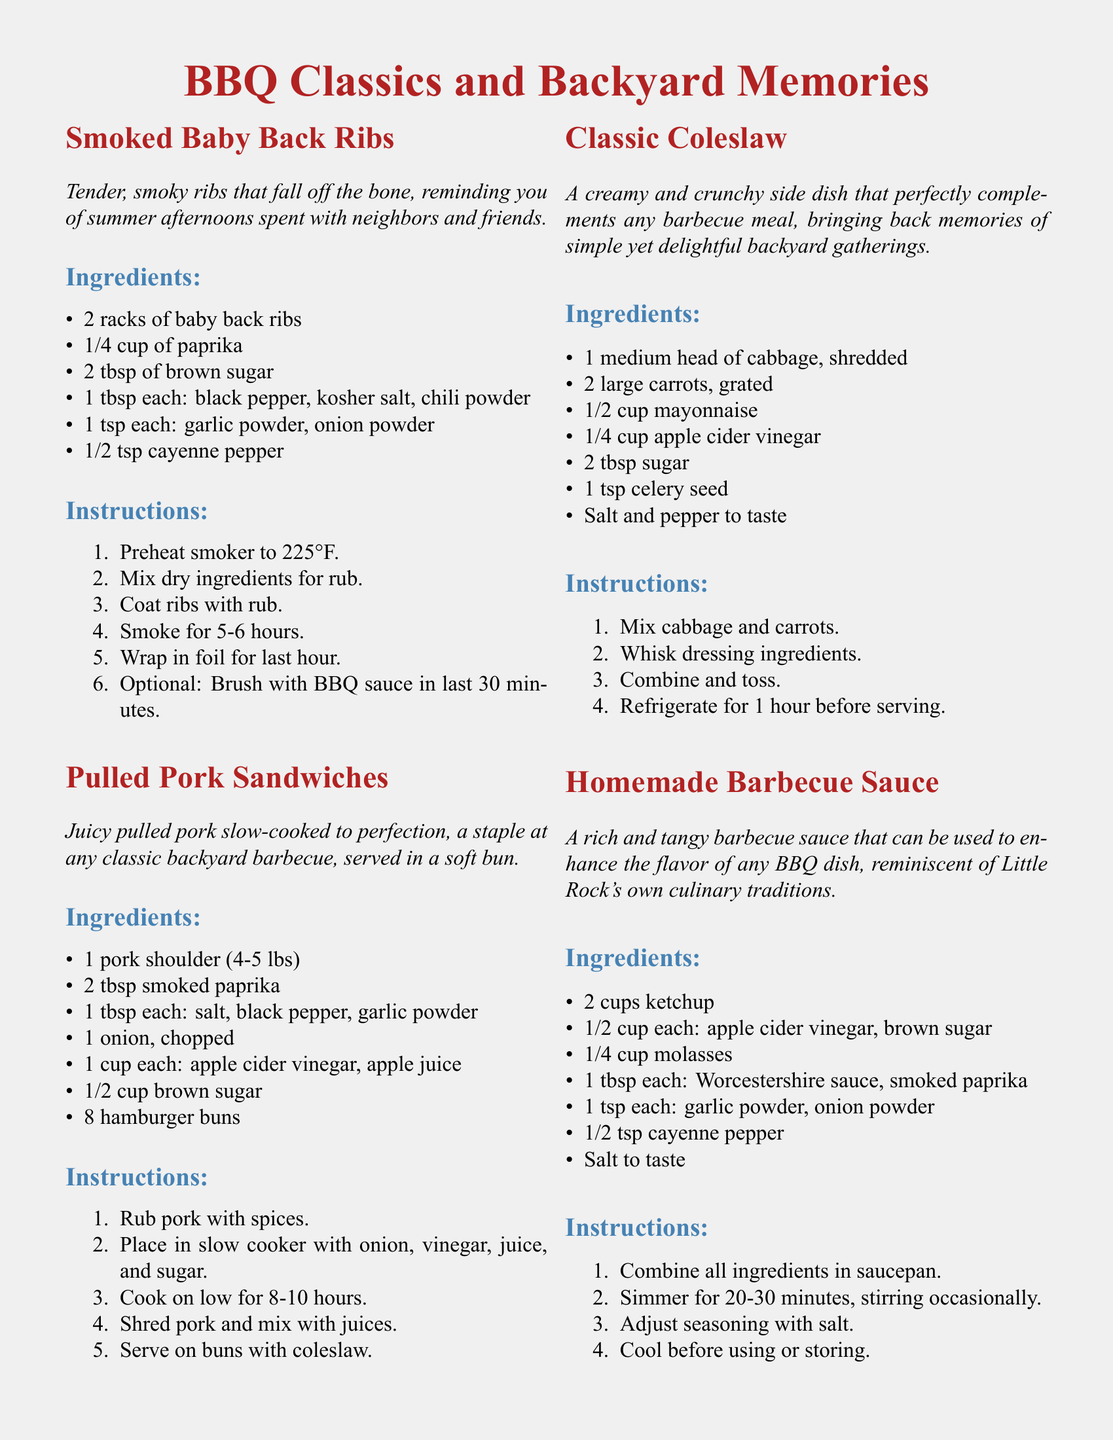What is the title of the document? The title of the document is prominently displayed at the top, "BBQ Classics and Backyard Memories."
Answer: BBQ Classics and Backyard Memories How many racks of ribs are needed for the Smoked Baby Back Ribs? According to the recipe for Smoked Baby Back Ribs, 2 racks of baby back ribs are required.
Answer: 2 racks What temperature should the smoker be preheated to? The instructions for the Smoked Baby Back Ribs state that the smoker should be preheated to 225°F.
Answer: 225°F What is the main ingredient in Pulled Pork Sandwiches? The main ingredient in Pulled Pork Sandwiches is a pork shoulder.
Answer: pork shoulder How long should the Pulled Pork be cooked in the slow cooker? The Pulled Pork should be cooked on low for 8-10 hours, as stated in the instructions.
Answer: 8-10 hours List one ingredient in the Classic Coleslaw. The Classic Coleslaw includes several ingredients, one of which is shredded cabbage.
Answer: shredded cabbage What key flavor does the Homemade Barbecue Sauce include? The Homemade Barbecue Sauce includes apple cider vinegar as one of its key flavors.
Answer: apple cider vinegar How should the Classic Coleslaw be prepared before serving? The Classic Coleslaw should be refrigerated for 1 hour before serving, according to the instructions.
Answer: Refrigerate for 1 hour What color is the page background? The page background color is mygray, a light shade described in the document.
Answer: mygray 